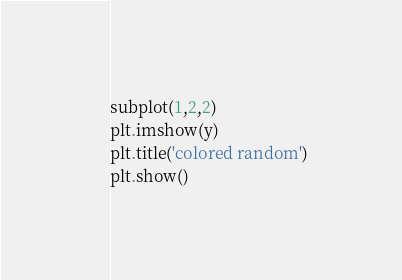<code> <loc_0><loc_0><loc_500><loc_500><_Python_>subplot(1,2,2)
plt.imshow(y)
plt.title('colored random')
plt.show()
</code> 